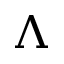Convert formula to latex. <formula><loc_0><loc_0><loc_500><loc_500>\Lambda</formula> 